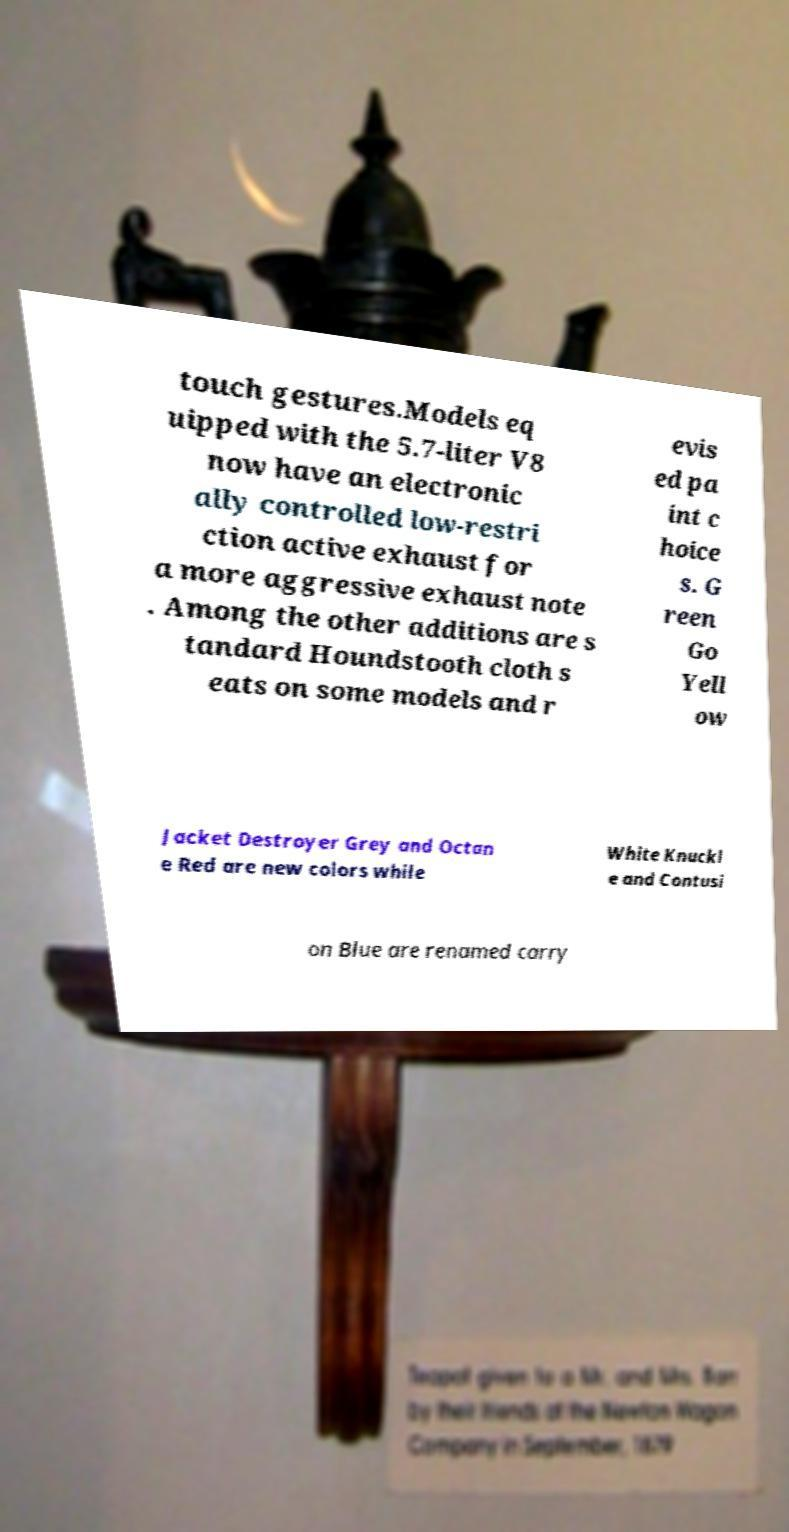For documentation purposes, I need the text within this image transcribed. Could you provide that? touch gestures.Models eq uipped with the 5.7-liter V8 now have an electronic ally controlled low-restri ction active exhaust for a more aggressive exhaust note . Among the other additions are s tandard Houndstooth cloth s eats on some models and r evis ed pa int c hoice s. G reen Go Yell ow Jacket Destroyer Grey and Octan e Red are new colors while White Knuckl e and Contusi on Blue are renamed carry 